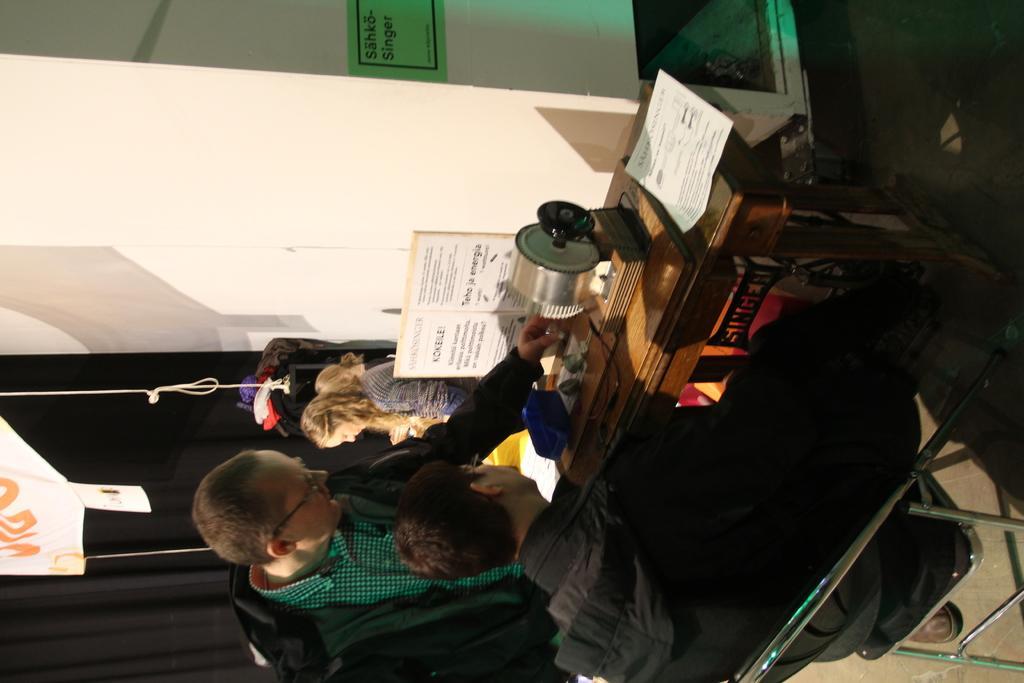In one or two sentences, can you explain what this image depicts? In this image in the center there are persons sitting and standing and there is a table on the table there is a machine and there is a paper with some text written on it, and there is a wall which is white in colour and on the wall there are posters with some text written on it. On the left side there is a black colour curtain and there is a banner hanging which is white in colour. 